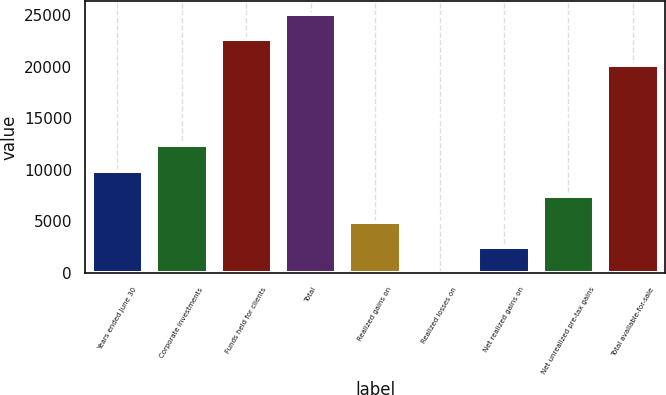<chart> <loc_0><loc_0><loc_500><loc_500><bar_chart><fcel>Years ended June 30<fcel>Corporate investments<fcel>Funds held for clients<fcel>Total<fcel>Realized gains on<fcel>Realized losses on<fcel>Net realized gains on<fcel>Net unrealized pre-tax gains<fcel>Total available-for-sale<nl><fcel>9921.9<fcel>12401.4<fcel>22636<fcel>25115.5<fcel>4962.9<fcel>3.9<fcel>2483.4<fcel>7442.4<fcel>20156.5<nl></chart> 